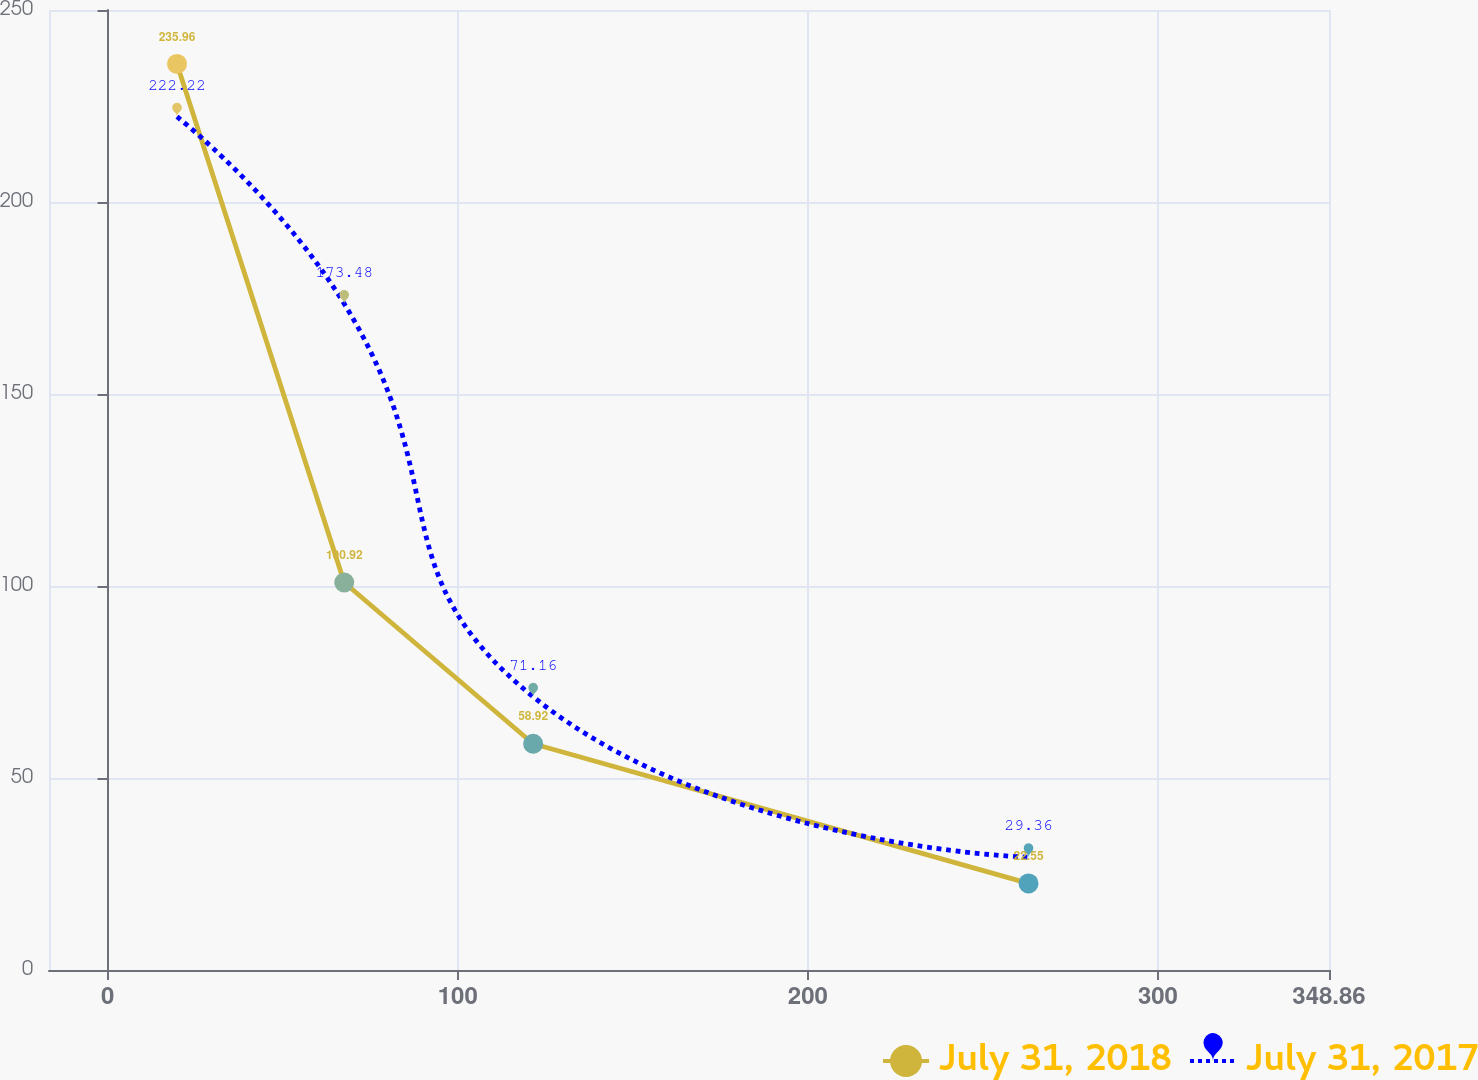Convert chart. <chart><loc_0><loc_0><loc_500><loc_500><line_chart><ecel><fcel>July 31, 2018<fcel>July 31, 2017<nl><fcel>19.82<fcel>235.96<fcel>222.22<nl><fcel>67.59<fcel>100.92<fcel>173.48<nl><fcel>121.55<fcel>58.92<fcel>71.16<nl><fcel>263.04<fcel>22.55<fcel>29.36<nl><fcel>385.42<fcel>386.3<fcel>447.32<nl></chart> 